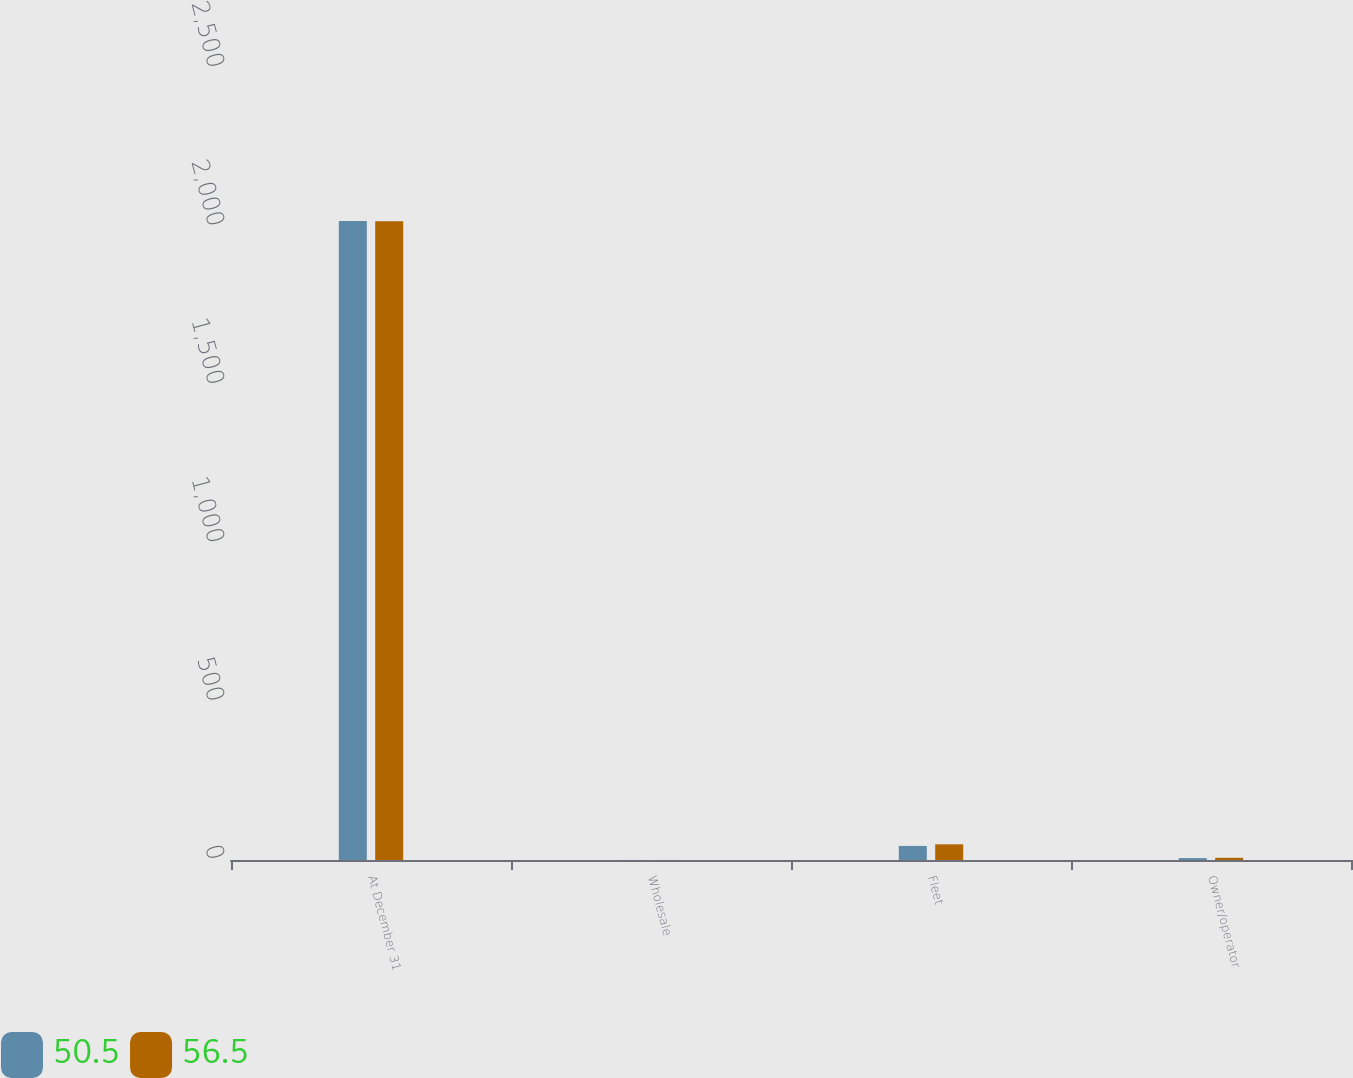Convert chart to OTSL. <chart><loc_0><loc_0><loc_500><loc_500><stacked_bar_chart><ecel><fcel>At December 31<fcel>Wholesale<fcel>Fleet<fcel>Owner/operator<nl><fcel>50.5<fcel>2017<fcel>0.1<fcel>44.4<fcel>6<nl><fcel>56.5<fcel>2016<fcel>0.1<fcel>49.5<fcel>6.9<nl></chart> 